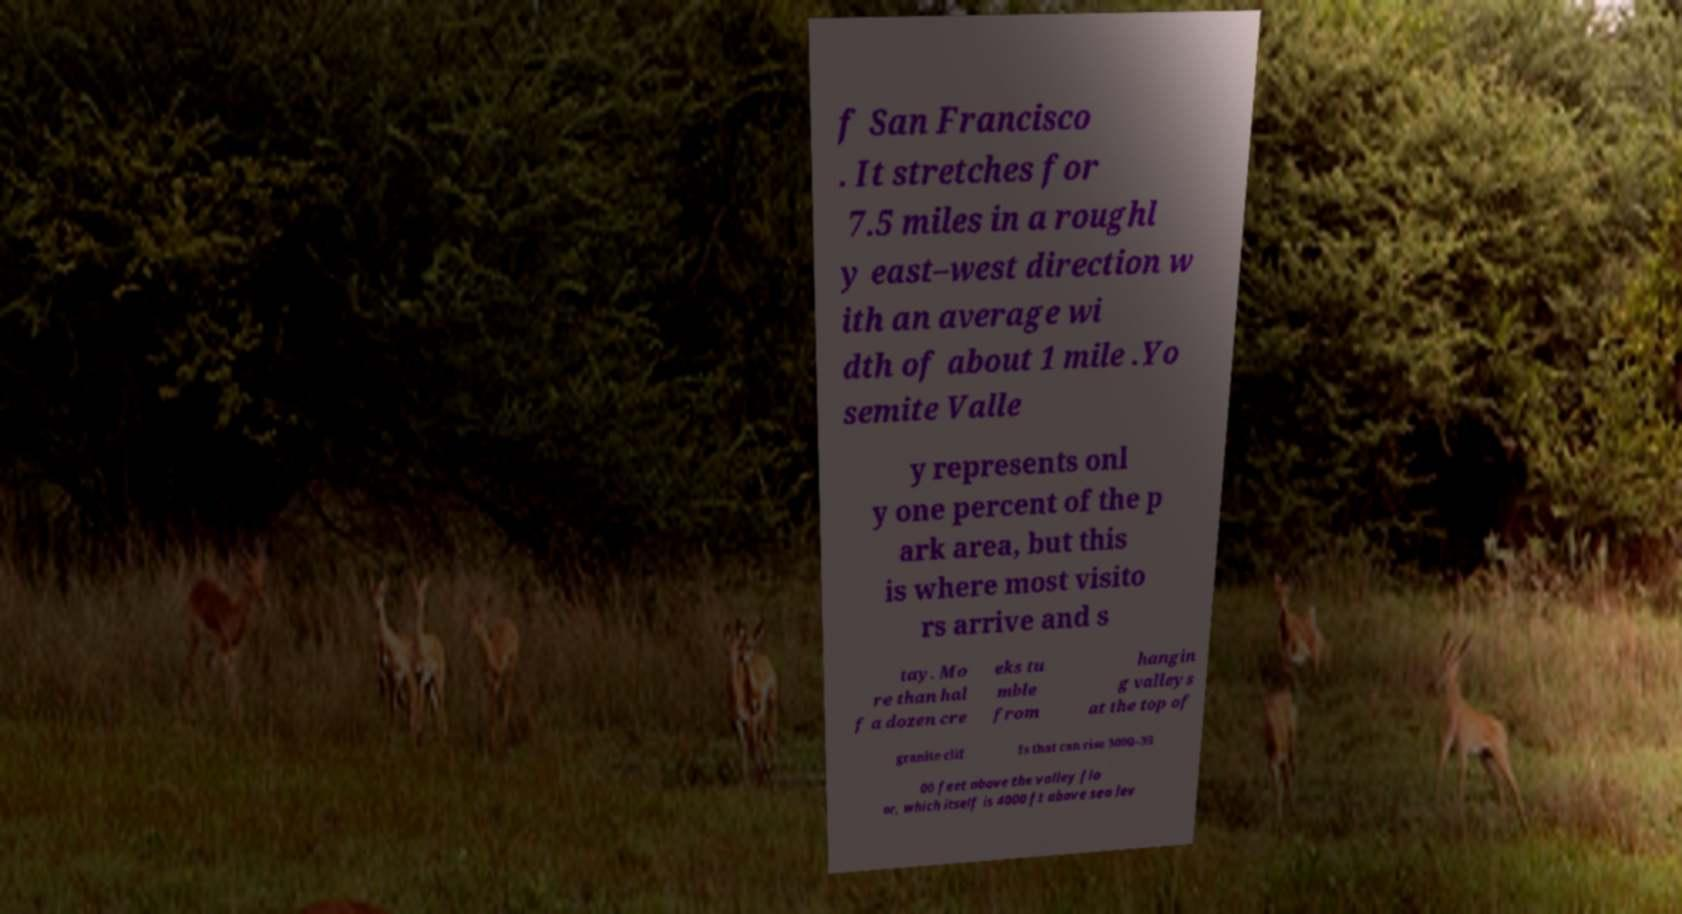Please read and relay the text visible in this image. What does it say? f San Francisco . It stretches for 7.5 miles in a roughl y east–west direction w ith an average wi dth of about 1 mile .Yo semite Valle y represents onl y one percent of the p ark area, but this is where most visito rs arrive and s tay. Mo re than hal f a dozen cre eks tu mble from hangin g valleys at the top of granite clif fs that can rise 3000–35 00 feet above the valley flo or, which itself is 4000 ft above sea lev 